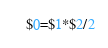<code> <loc_0><loc_0><loc_500><loc_500><_Awk_>$0=$1*$2/2
</code> 